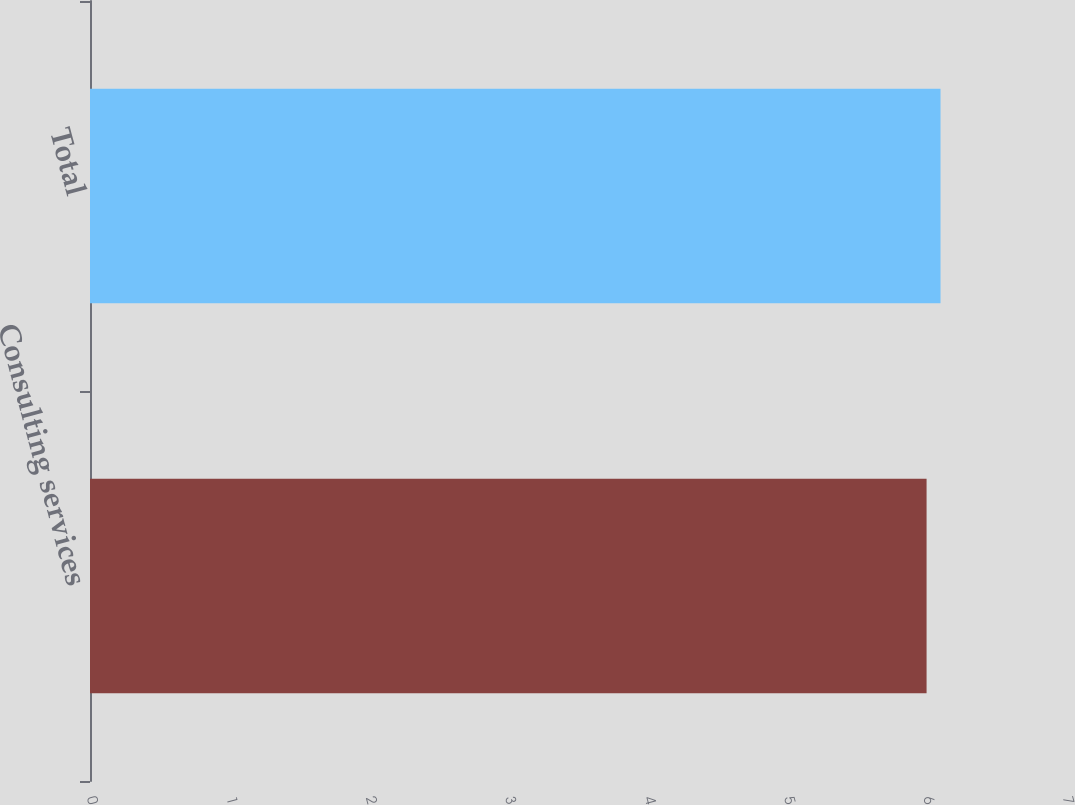<chart> <loc_0><loc_0><loc_500><loc_500><bar_chart><fcel>Consulting services<fcel>Total<nl><fcel>6<fcel>6.1<nl></chart> 